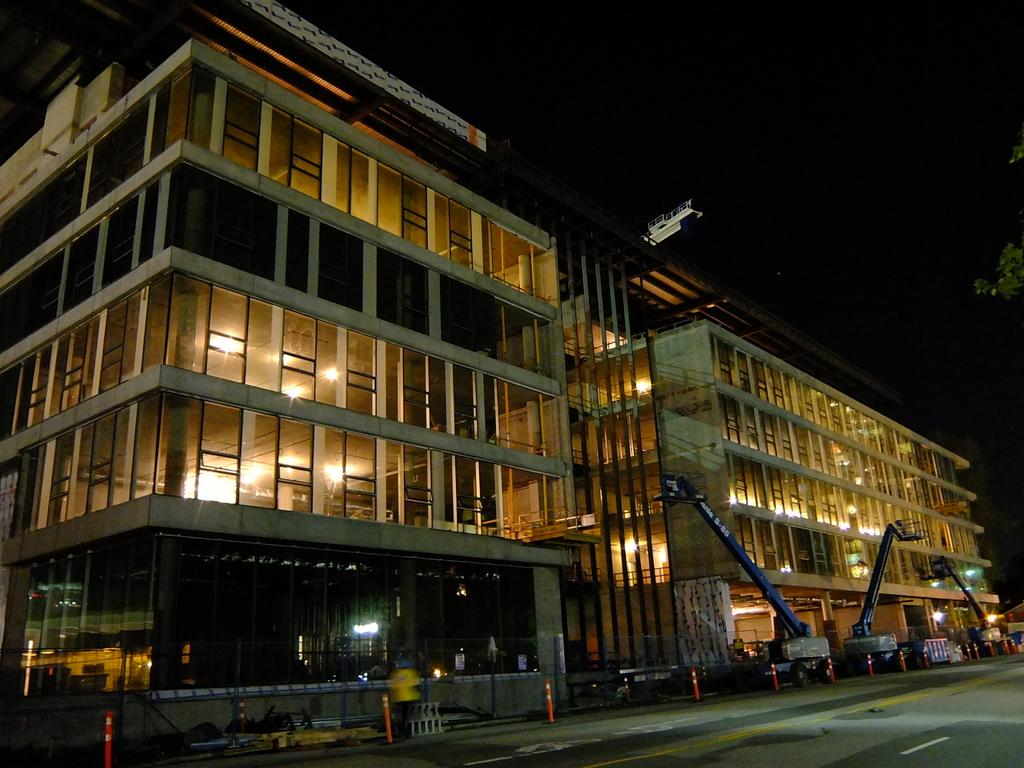What is located in the center of the image? There are buildings in the center of the image. What can be seen on the road in the image? There are safety poles and vehicles on the road. What is visible at the top of the image? The sky is visible at the top of the image. Where is the hospital located in the image? There is no hospital mentioned or visible in the image. What type of copper object can be seen on the road? There is no copper object present in the image. 